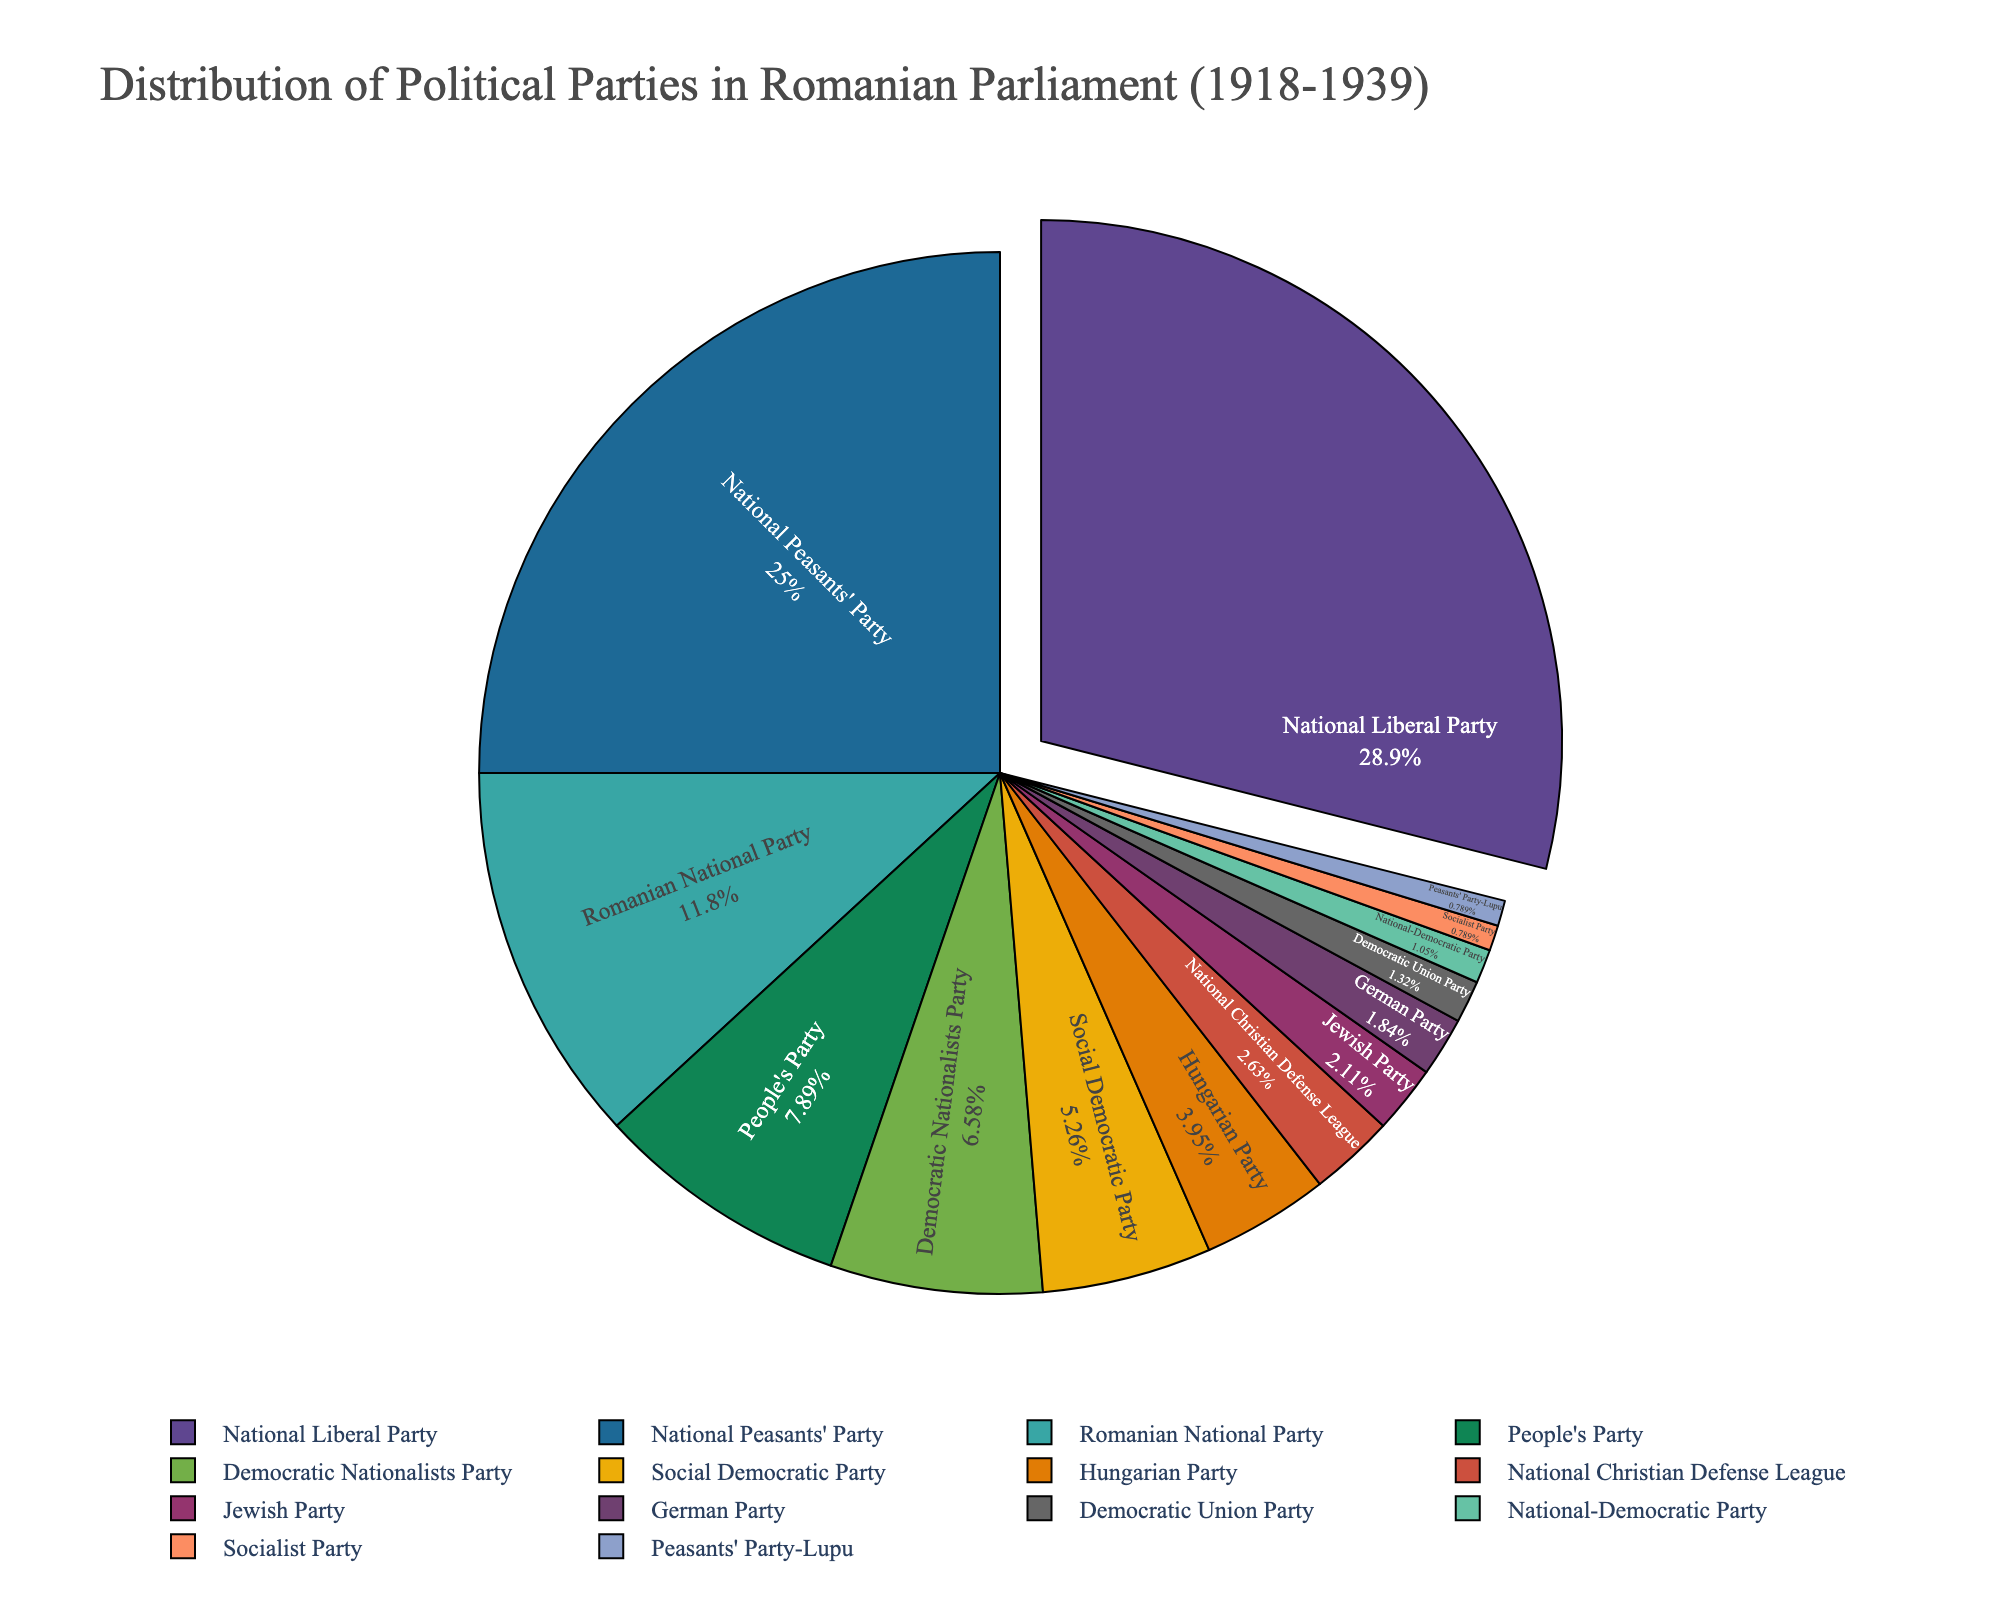What percentage of parliamentary seats did the National Liberal Party hold? To answer this, locate the National Liberal Party in the pie chart and identify the percentage given. This can be directly read off the section of the pie chart corresponding to the National Liberal Party.
Answer: 25.3% How many more seats did the National Peasants' Party hold compared to the Social Democratic Party? Find the number of seats for the National Peasants' Party (95) and the Social Democratic Party (20). Subtract the Social Democratic Party's seats from the National Peasants' Party's seats: 95 - 20 = 75.
Answer: 75 Which party has more parliamentary seats: the Hungarian Party or the National Christian Defense League? Locate the portions of the pie chart corresponding to the Hungarian Party and the National Christian Defense League. Identify and compare their seat counts (15 for the Hungarian Party and 10 for the National Christian Defense League).
Answer: Hungarian Party What fraction of the total seats are held by the National Liberal Party, National Peasants' Party, and Romanian National Party combined? Add the seats of National Liberal Party (110), National Peasants' Party (95), and Romanian National Party (45): 110 + 95 + 45 = 250. Assuming the total number of seats is 380 (sum of all party seats), the fraction is 250/380.
Answer: 250/380 or approximately 65.8% Are there more seats held by minority parties (Hungarian, Jewish, German) or the Democratic Nationalists Party? Sum the seats of the Hungarian Party (15), Jewish Party (8), and German Party (7): 15 + 8 + 7 = 30. Compare this with the seats of the Democratic Nationalists Party (25).
Answer: Minority Parties Which party held the least number of seats, and how many? Find the smallest slice in the pie chart associated with the fewest seats and identify the party by its label.
Answer: Socialist Party with 3 seats What is the combined percentage of seats held by the People's Party and the Democratic Union Party? Locate and identify the percentages each holds: People's Party (30 seats) and Democratic Union Party (5 seats). Calculate the combined percentage using the seat counts, assuming the total seats is 380. The combined percentage is approximately 7.9%.
Answer: Approximately 7.9% Which two parties have the smallest difference in their number of seats? Compare the seat counts for all parties. The smallest difference is between the Democratic Union Party (5) and the National-Democratic Party (4), which is 1 seat.
Answer: Democratic Union Party and National-Democratic Party 